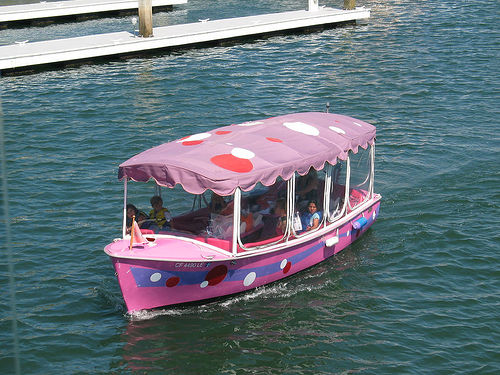Is the clarity of the image above average?
A. No
B. Yes
Answer with the option's letter from the given choices directly.
 B. 